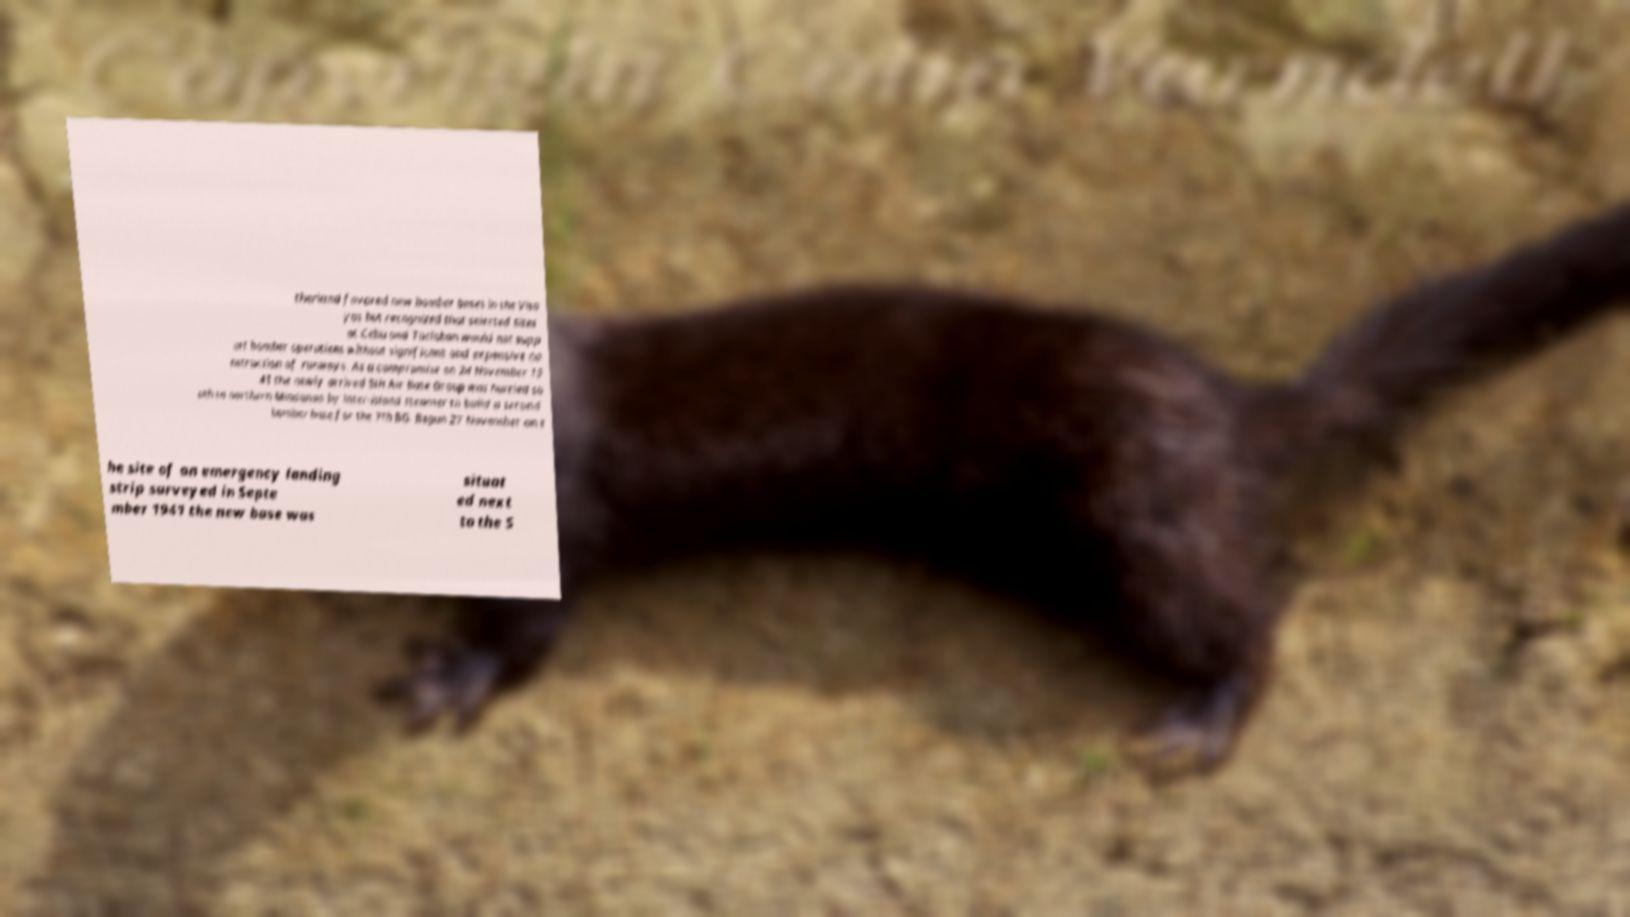Please read and relay the text visible in this image. What does it say? therland favored new bomber bases in the Visa yas but recognized that selected sites at Cebu and Tacloban would not supp ort bomber operations without significant and expensive co nstruction of runways. As a compromise on 24 November 19 41 the newly arrived 5th Air Base Group was hurried so uth to northern Mindanao by inter-island steamer to build a second bomber base for the 7th BG. Begun 27 November on t he site of an emergency landing strip surveyed in Septe mber 1941 the new base was situat ed next to the S 